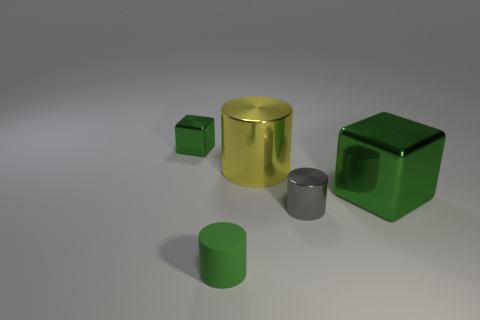What number of objects are either big objects or big green spheres?
Your response must be concise. 2. Do the yellow object and the tiny thing behind the large green metal block have the same material?
Ensure brevity in your answer.  Yes. Is there any other thing that is the same color as the tiny matte cylinder?
Your answer should be compact. Yes. What number of things are green things behind the big yellow metallic object or green metallic things to the left of the small metal cylinder?
Ensure brevity in your answer.  1. The green object that is on the left side of the big green block and behind the gray shiny thing has what shape?
Ensure brevity in your answer.  Cube. How many gray metal objects are right of the cylinder that is behind the big green metallic block?
Your answer should be compact. 1. Is there anything else that is the same material as the yellow cylinder?
Your answer should be compact. Yes. How many objects are things to the right of the green rubber cylinder or small green matte cylinders?
Your answer should be very brief. 4. There is a block that is to the left of the big green shiny thing; what is its size?
Your answer should be very brief. Small. What is the material of the tiny gray thing?
Provide a short and direct response. Metal. 